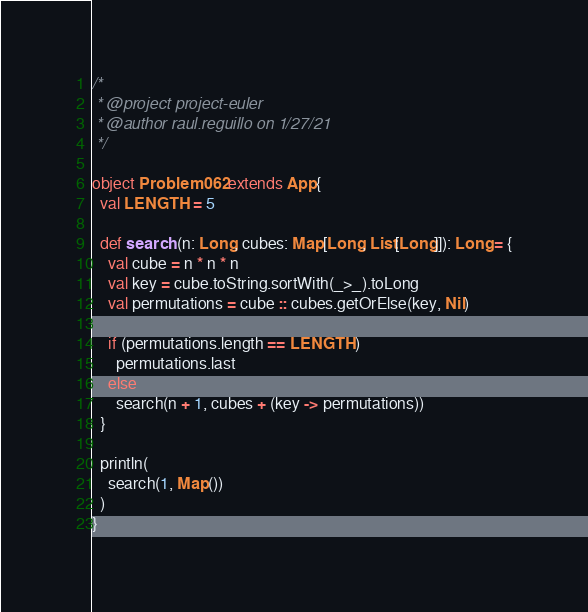<code> <loc_0><loc_0><loc_500><loc_500><_Scala_>/* 
 * @project project-euler
 * @author raul.reguillo on 1/27/21
 */

object Problem062 extends App{
  val LENGTH = 5

  def search (n: Long, cubes: Map[Long, List[Long]]): Long = {
    val cube = n * n * n
    val key = cube.toString.sortWith(_>_).toLong
    val permutations = cube :: cubes.getOrElse(key, Nil)

    if (permutations.length == LENGTH)
      permutations.last
    else
      search(n + 1, cubes + (key -> permutations))
  }

  println(
    search(1, Map())
  )
}
</code> 